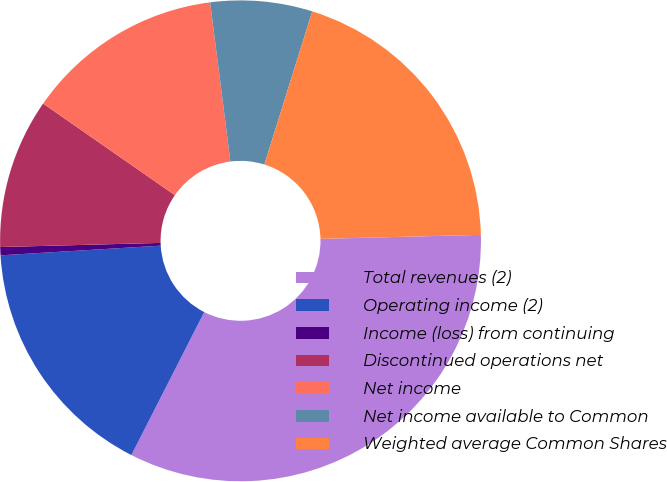Convert chart. <chart><loc_0><loc_0><loc_500><loc_500><pie_chart><fcel>Total revenues (2)<fcel>Operating income (2)<fcel>Income (loss) from continuing<fcel>Discontinued operations net<fcel>Net income<fcel>Net income available to Common<fcel>Weighted average Common Shares<nl><fcel>32.89%<fcel>16.54%<fcel>0.55%<fcel>10.08%<fcel>13.31%<fcel>6.84%<fcel>19.78%<nl></chart> 